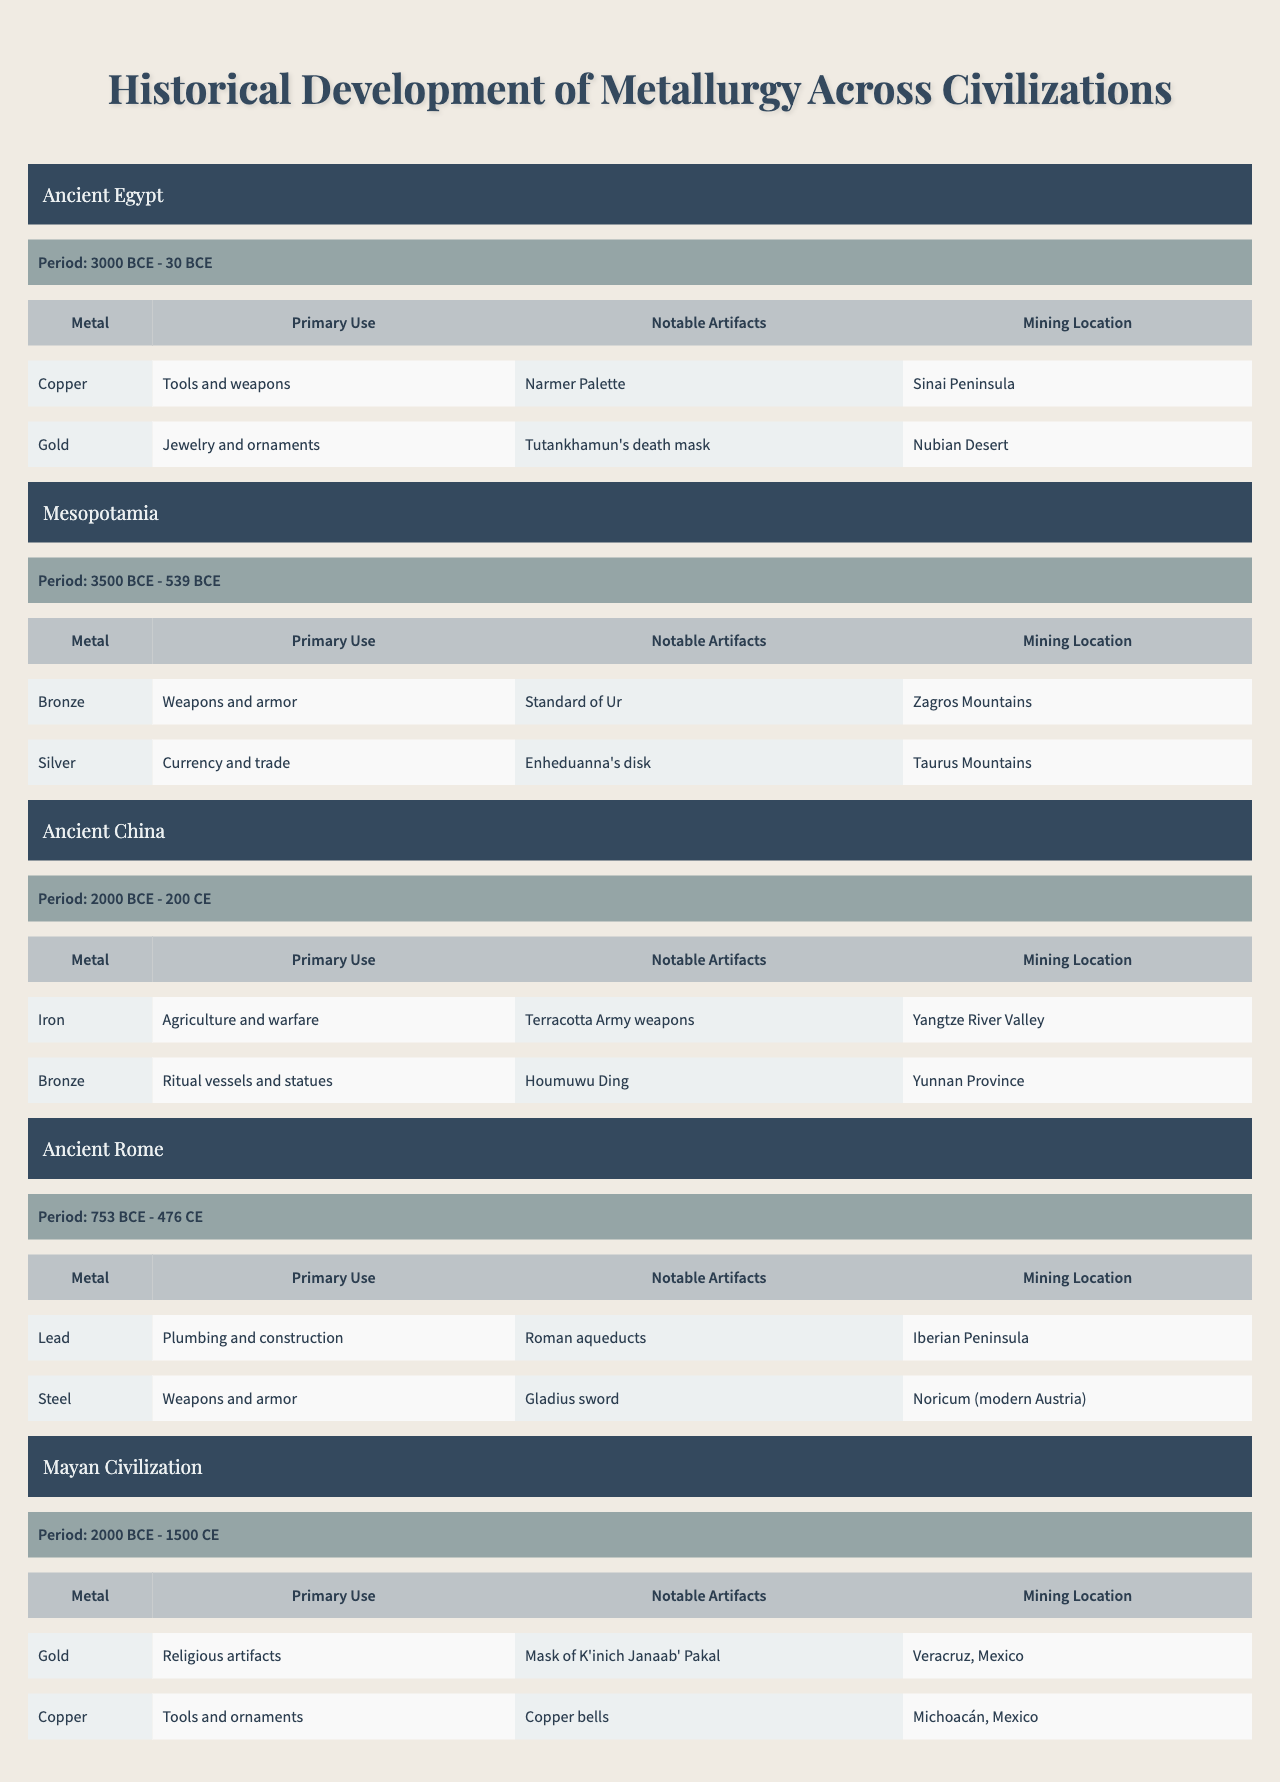What is the primary metal used in Ancient Egypt for tools and weapons? Ancient Egypt lists copper as a major metal with a primary use for tools and weapons, as indicated in the table.
Answer: Copper During which period did the Mesopotamian civilization utilize bronze? The table specifies that the Mesopotamian civilization used bronze from 3500 BCE to 539 BCE.
Answer: 3500 BCE - 539 BCE Is silver listed as a notable metal in Ancient China? The table shows that silver is not mentioned as a major metal in Ancient China; thus, the answer is false.
Answer: No What notable artifact is associated with gold in the Mayan civilization? The Mayan civilization mentions the "Mask of K'inich Janaab' Pakal" as a notable artifact related to gold.
Answer: Mask of K'inich Janaab' Pakal Which civilization had the longest period of metallurgy? By comparing the periods, Mesopotamia (3500 BCE - 539 BCE) spans 2961 years, which is the longest period listed in the table.
Answer: Mesopotamia What is the primary use of iron in Ancient China? The table indicates that the primary use of iron in Ancient China was for agriculture and warfare.
Answer: Agriculture and warfare Which civilization primarily mined its metals from the Sinai Peninsula? The table shows that Ancient Egypt mined copper from the Sinai Peninsula.
Answer: Ancient Egypt If we consider the metals used in Ancient Rome, which metal was not associated with creating weapons or armor? The table states that lead's primary use in Ancient Rome was plumbing and construction, while steel is used for weapons and armor. Hence, lead is the answer.
Answer: Lead In terms of mining locations, which civilization mined copper in Michoacán, Mexico? The table states that the Mayan civilization mined copper in Michoacán, Mexico.
Answer: Mayan Civilization How many major metals are noted for Ancient China, and what are they? Ancient China has two major metals listed: iron and bronze, as displayed in the table.
Answer: Two: Iron and Bronze Which civilization's notable artifacts include the "Gladius sword"? The table specifies that the "Gladius sword" is a notable artifact of Ancient Rome.
Answer: Ancient Rome 